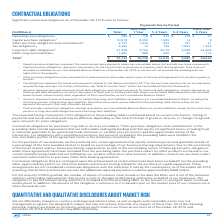From Intel Corporation's financial document, What are the types of contractual obligations in the table? The document contains multiple relevant values: Operating lease obligations, Capital purchase obligations, Other purchase obligations and commitments, Tax obligations, Long-term debt obligations, Other long-term liabilities. From the document: "Operating lease obligations 1 $ 595 $ 178 $ 232 $ 128 $ 57 Capital purchase obligations 2 10,918 9,300 1,595 14 9 Other long-term liabilities 6 1,692 ..." Also, What payments do Other purchase obligations and commitments include? include payments due under various types of licenses and agreements to purchase goods or services.. The document states: "3 Other purchase obligations and commitments include payments due under various types of licenses and agreements to purchase goods or services...." Also, Why are derivative instruments excluded from the preceding table? Because they do not represent the amounts that may ultimately be paid.. The document states: "instruments are excluded from the preceding table, because they do not represent the amounts that may ultimately be paid...." Also, can you calculate: What is the capital purchase obligations expressed as a percentage of the contractual obligations that is due in less than 1 year? Based on the calculation: 9,300/16,728, the result is 55.6 (percentage). This is based on the information: "Capital purchase obligations 2 10,918 9,300 1,595 14 9 Total 7 $ 61,732 $ 16,728 $ 12,670 $ 5,690 $ 26,644..." The key data points involved are: 16,728, 9,300. Additionally, Which Payments Due by Period has the highest total contractual obligation? According to the financial document, More Than 5 Years. The relevant text states: "More Than 5 Years..." Also, can you calculate: What is the percentage change of total liabilities due from Less than 1 year to 1-3 years? To answer this question, I need to perform calculations using the financial data. The calculation is: (12,670-16,728)/16,728, which equals -24.26 (percentage). This is based on the information: "Total 7 $ 61,732 $ 16,728 $ 12,670 $ 5,690 $ 26,644 Total 7 $ 61,732 $ 16,728 $ 12,670 $ 5,690 $ 26,644..." The key data points involved are: 12,670, 16,728. 